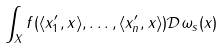Convert formula to latex. <formula><loc_0><loc_0><loc_500><loc_500>\int _ { X } f ( \langle x _ { 1 } ^ { \prime } , x \rangle , \dots , \langle x _ { n } ^ { \prime } , x \rangle ) \mathcal { D } \omega _ { s } ( x )</formula> 